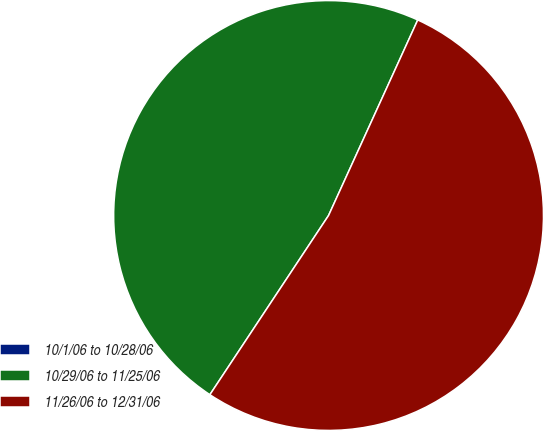Convert chart to OTSL. <chart><loc_0><loc_0><loc_500><loc_500><pie_chart><fcel>10/1/06 to 10/28/06<fcel>10/29/06 to 11/25/06<fcel>11/26/06 to 12/31/06<nl><fcel>0.0%<fcel>47.5%<fcel>52.5%<nl></chart> 